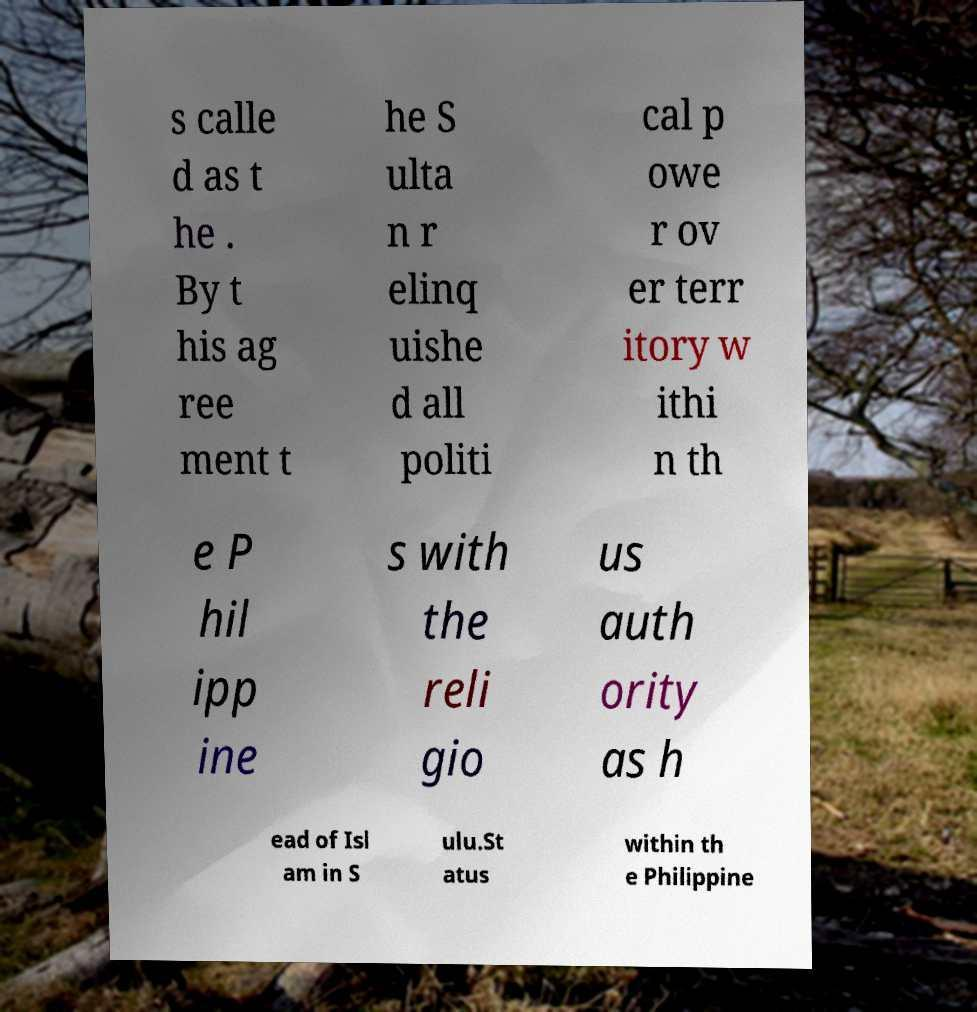What messages or text are displayed in this image? I need them in a readable, typed format. s calle d as t he . By t his ag ree ment t he S ulta n r elinq uishe d all politi cal p owe r ov er terr itory w ithi n th e P hil ipp ine s with the reli gio us auth ority as h ead of Isl am in S ulu.St atus within th e Philippine 